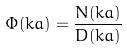Convert formula to latex. <formula><loc_0><loc_0><loc_500><loc_500>\Phi ( k a ) = \frac { N ( k a ) } { D ( k a ) }</formula> 